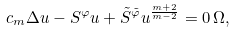Convert formula to latex. <formula><loc_0><loc_0><loc_500><loc_500>c _ { m } \Delta u - S ^ { \varphi } u + \tilde { S } ^ { \tilde { \varphi } } u ^ { \frac { m + 2 } { m - 2 } } = 0 \, \Omega ,</formula> 